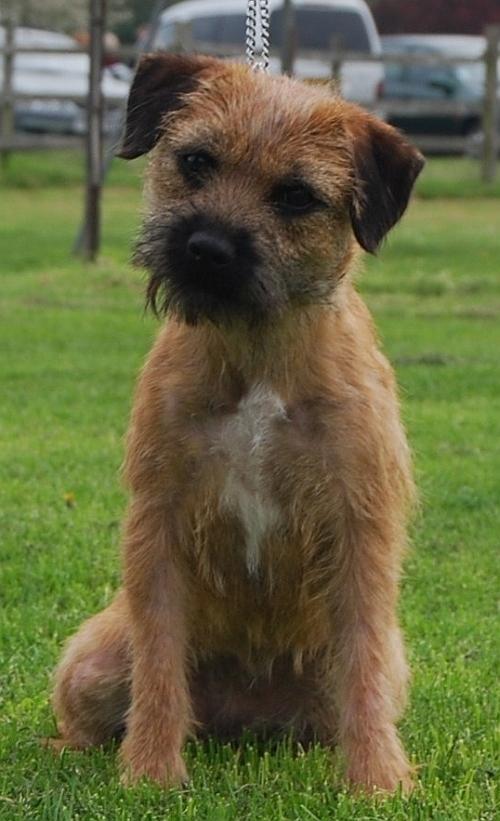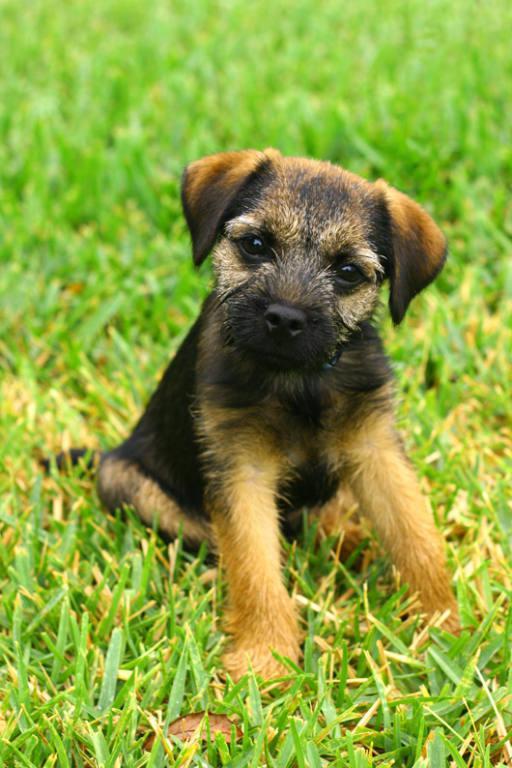The first image is the image on the left, the second image is the image on the right. Analyze the images presented: Is the assertion "The animal in the image on the left is not looking toward the camera." valid? Answer yes or no. No. 